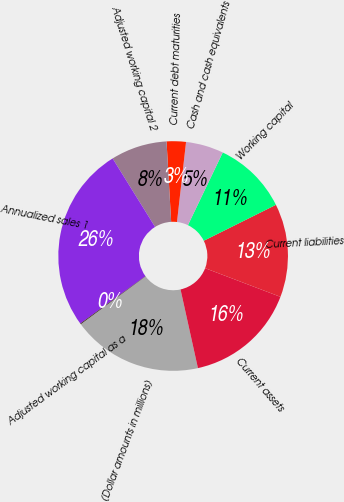Convert chart to OTSL. <chart><loc_0><loc_0><loc_500><loc_500><pie_chart><fcel>(Dollar amounts in millions)<fcel>Current assets<fcel>Current liabilities<fcel>Working capital<fcel>Cash and cash equivalents<fcel>Current debt maturities<fcel>Adjusted working capital 2<fcel>Annualized sales 1<fcel>Adjusted working capital as a<nl><fcel>18.35%<fcel>15.75%<fcel>13.14%<fcel>10.53%<fcel>5.32%<fcel>2.71%<fcel>7.92%<fcel>26.18%<fcel>0.1%<nl></chart> 